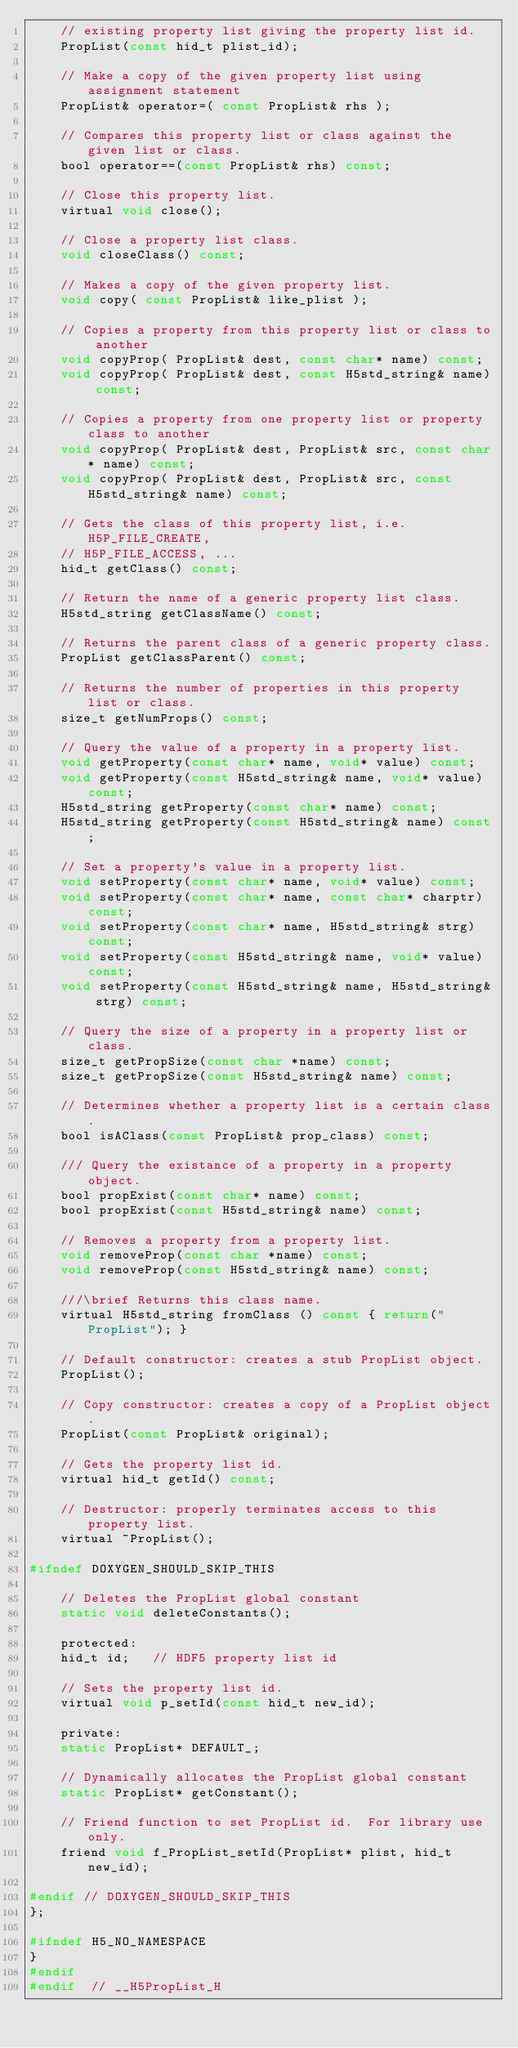Convert code to text. <code><loc_0><loc_0><loc_500><loc_500><_C_>	// existing property list giving the property list id.
	PropList(const hid_t plist_id);

	// Make a copy of the given property list using assignment statement
	PropList& operator=( const PropList& rhs );

	// Compares this property list or class against the given list or class.
	bool operator==(const PropList& rhs) const;

	// Close this property list.
	virtual void close();

	// Close a property list class.
	void closeClass() const;

	// Makes a copy of the given property list.
	void copy( const PropList& like_plist );

	// Copies a property from this property list or class to another
	void copyProp( PropList& dest, const char* name) const;
	void copyProp( PropList& dest, const H5std_string& name) const;

	// Copies a property from one property list or property class to another
	void copyProp( PropList& dest, PropList& src, const char* name) const;
	void copyProp( PropList& dest, PropList& src, const H5std_string& name) const;

	// Gets the class of this property list, i.e. H5P_FILE_CREATE,
	// H5P_FILE_ACCESS, ...
	hid_t getClass() const;

	// Return the name of a generic property list class.
	H5std_string getClassName() const;

	// Returns the parent class of a generic property class.
	PropList getClassParent() const;

	// Returns the number of properties in this property list or class.
	size_t getNumProps() const;

	// Query the value of a property in a property list.
	void getProperty(const char* name, void* value) const;
	void getProperty(const H5std_string& name, void* value) const;
	H5std_string getProperty(const char* name) const;
	H5std_string getProperty(const H5std_string& name) const;

	// Set a property's value in a property list.
	void setProperty(const char* name, void* value) const;
	void setProperty(const char* name, const char* charptr) const;
	void setProperty(const char* name, H5std_string& strg) const;
	void setProperty(const H5std_string& name, void* value) const;
	void setProperty(const H5std_string& name, H5std_string& strg) const;

	// Query the size of a property in a property list or class.
	size_t getPropSize(const char *name) const;
	size_t getPropSize(const H5std_string& name) const;

	// Determines whether a property list is a certain class.
	bool isAClass(const PropList& prop_class) const;

	/// Query the existance of a property in a property object.
	bool propExist(const char* name) const;
	bool propExist(const H5std_string& name) const;

	// Removes a property from a property list.
	void removeProp(const char *name) const;
	void removeProp(const H5std_string& name) const;

	///\brief Returns this class name.
	virtual H5std_string fromClass () const { return("PropList"); }

	// Default constructor: creates a stub PropList object.
	PropList();

	// Copy constructor: creates a copy of a PropList object.
	PropList(const PropList& original);

	// Gets the property list id.
	virtual hid_t getId() const;

	// Destructor: properly terminates access to this property list.
	virtual ~PropList();

#ifndef DOXYGEN_SHOULD_SKIP_THIS

	// Deletes the PropList global constant
	static void deleteConstants();

    protected:
	hid_t id;	// HDF5 property list id

	// Sets the property list id.
	virtual void p_setId(const hid_t new_id);

    private:
	static PropList* DEFAULT_;

	// Dynamically allocates the PropList global constant
	static PropList* getConstant();

	// Friend function to set PropList id.  For library use only.
	friend void f_PropList_setId(PropList* plist, hid_t new_id);

#endif // DOXYGEN_SHOULD_SKIP_THIS
};

#ifndef H5_NO_NAMESPACE
}
#endif
#endif  // __H5PropList_H
</code> 